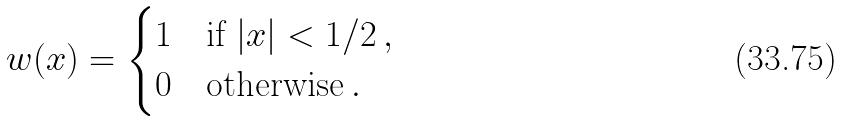<formula> <loc_0><loc_0><loc_500><loc_500>w ( x ) = \begin{cases} 1 & \text {if $|x| < 1/2 \, ,$} \\ 0 & \text {otherwise$\, .$} \end{cases}</formula> 